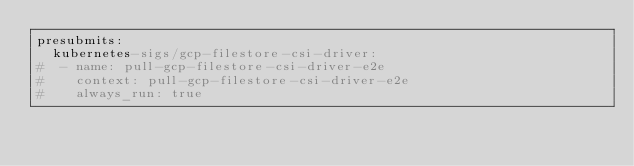<code> <loc_0><loc_0><loc_500><loc_500><_YAML_>presubmits:
  kubernetes-sigs/gcp-filestore-csi-driver:
#  - name: pull-gcp-filestore-csi-driver-e2e
#    context: pull-gcp-filestore-csi-driver-e2e
#    always_run: true</code> 